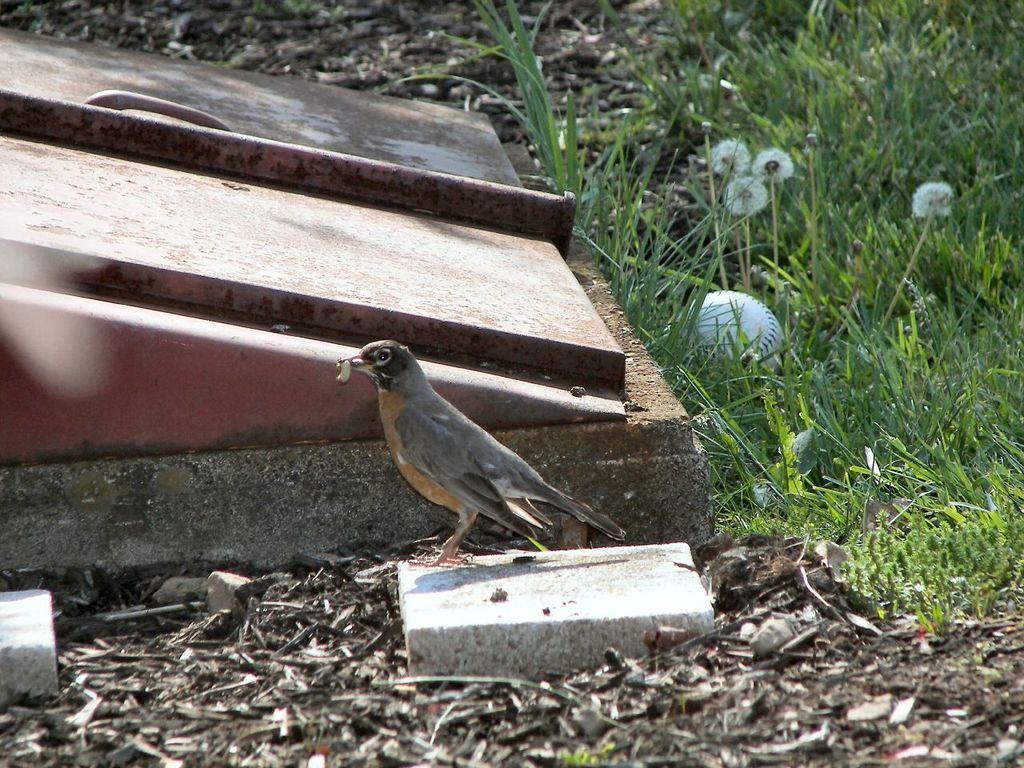Please provide a concise description of this image. In this image, we can see a bird is holding some object in mouth. Background we can see some object, handle, grass, flowers. Here there is a white ball. 